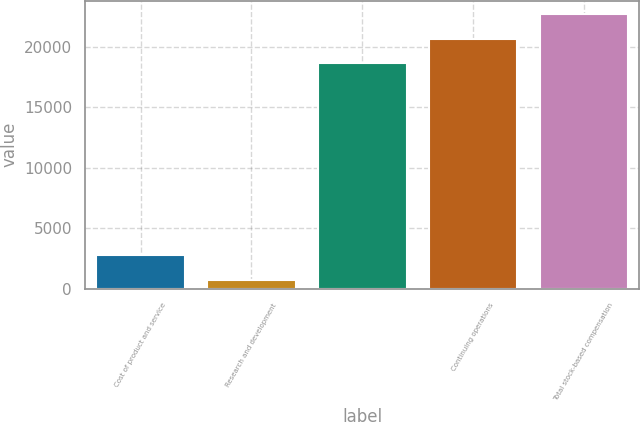Convert chart to OTSL. <chart><loc_0><loc_0><loc_500><loc_500><bar_chart><fcel>Cost of product and service<fcel>Research and development<fcel>Unnamed: 2<fcel>Continuing operations<fcel>Total stock-based compensation<nl><fcel>2775.4<fcel>747<fcel>18631<fcel>20659.4<fcel>22687.8<nl></chart> 